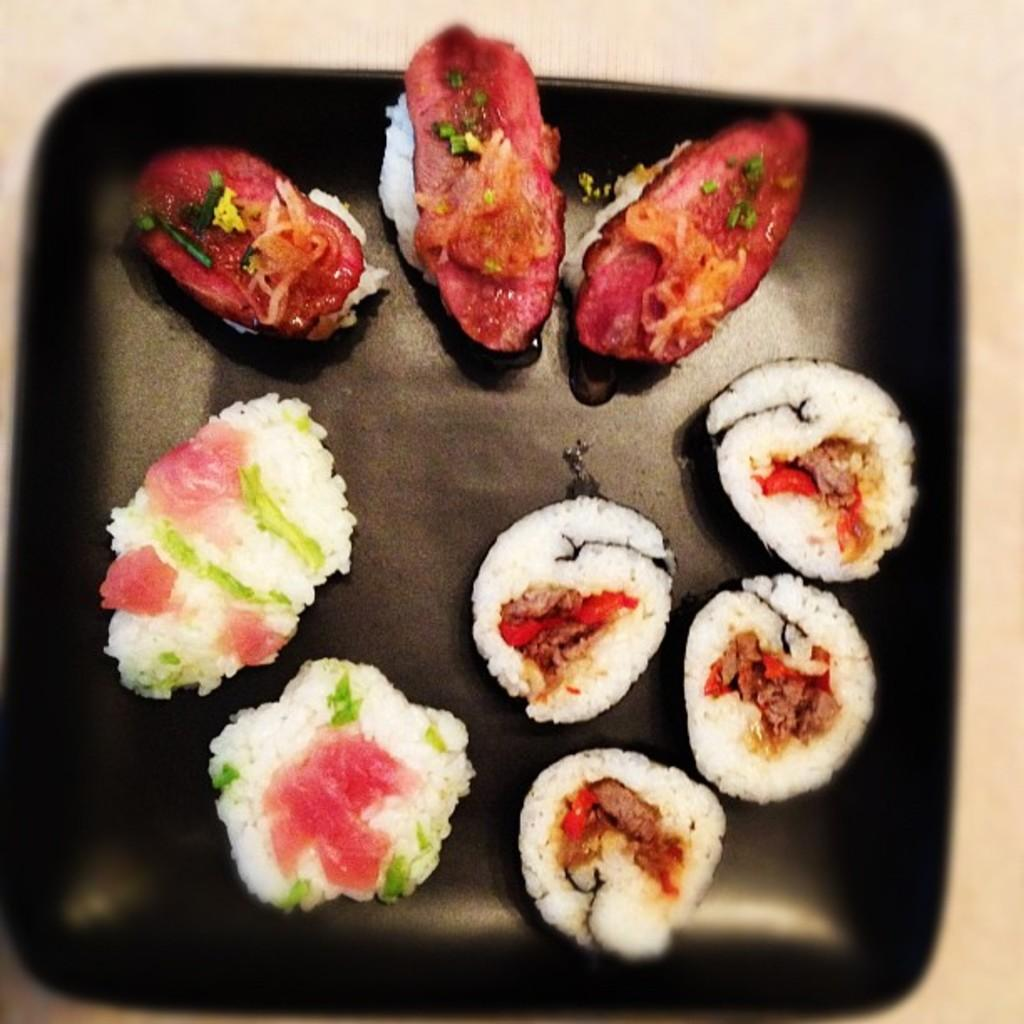What is the color of the tray in the image? The tray in the image is black. What type of food is on the tray? There are slices of meat on the tray. Are there any other food items on the tray besides the meat? Yes, there are other food items on the tray. How many chickens are visible on the tray in the image? There are no chickens visible on the tray in the image; only slices of meat and other food items are present. What type of twist can be seen in the image? There is no twist present in the image. 